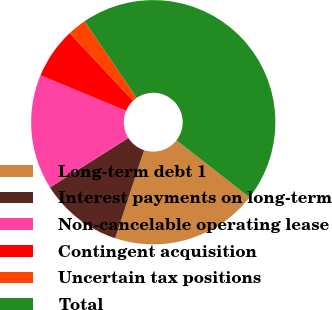Convert chart. <chart><loc_0><loc_0><loc_500><loc_500><pie_chart><fcel>Long-term debt 1<fcel>Interest payments on long-term<fcel>Non-cancelable operating lease<fcel>Contingent acquisition<fcel>Uncertain tax positions<fcel>Total<nl><fcel>19.5%<fcel>10.99%<fcel>15.25%<fcel>6.73%<fcel>2.48%<fcel>45.05%<nl></chart> 